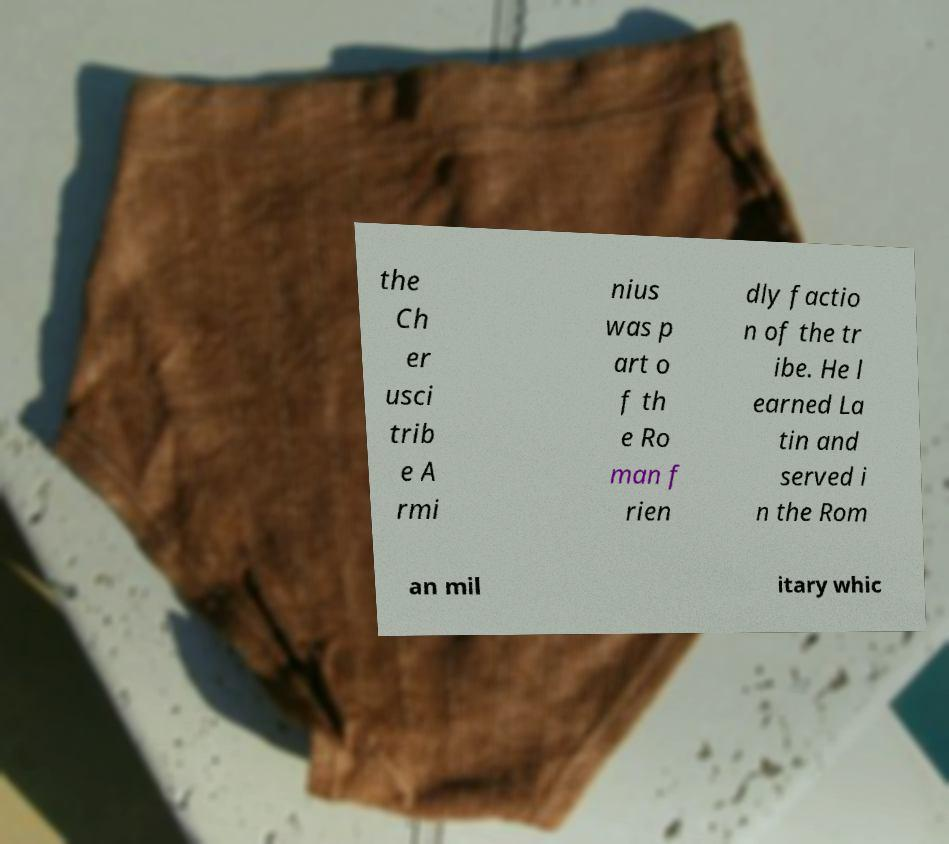Could you assist in decoding the text presented in this image and type it out clearly? the Ch er usci trib e A rmi nius was p art o f th e Ro man f rien dly factio n of the tr ibe. He l earned La tin and served i n the Rom an mil itary whic 